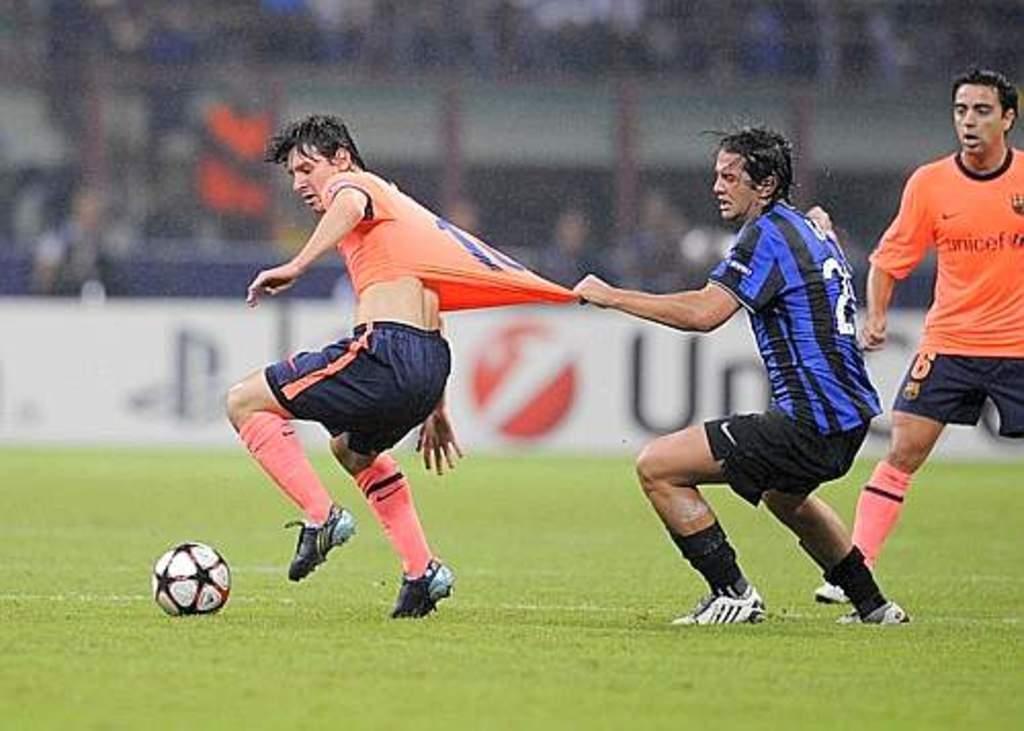Please provide a concise description of this image. Background portion of the picture is blurry and we can see a board. In this picture we can see the players. We can see a ball and green ground carpet. 